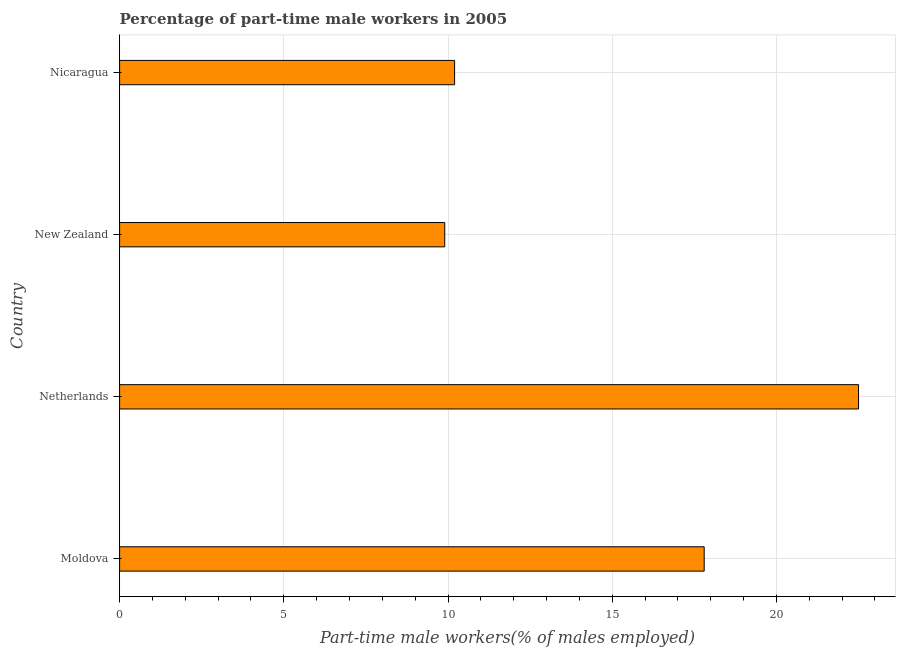Does the graph contain any zero values?
Make the answer very short. No. Does the graph contain grids?
Keep it short and to the point. Yes. What is the title of the graph?
Ensure brevity in your answer.  Percentage of part-time male workers in 2005. What is the label or title of the X-axis?
Your answer should be very brief. Part-time male workers(% of males employed). What is the percentage of part-time male workers in Nicaragua?
Your answer should be compact. 10.2. Across all countries, what is the minimum percentage of part-time male workers?
Provide a succinct answer. 9.9. In which country was the percentage of part-time male workers maximum?
Offer a terse response. Netherlands. In which country was the percentage of part-time male workers minimum?
Offer a very short reply. New Zealand. What is the sum of the percentage of part-time male workers?
Provide a short and direct response. 60.4. What is the difference between the percentage of part-time male workers in Netherlands and New Zealand?
Your response must be concise. 12.6. What is the average percentage of part-time male workers per country?
Your response must be concise. 15.1. What is the median percentage of part-time male workers?
Offer a very short reply. 14. In how many countries, is the percentage of part-time male workers greater than 19 %?
Provide a short and direct response. 1. What is the ratio of the percentage of part-time male workers in New Zealand to that in Nicaragua?
Your response must be concise. 0.97. Is the difference between the percentage of part-time male workers in New Zealand and Nicaragua greater than the difference between any two countries?
Ensure brevity in your answer.  No. Is the sum of the percentage of part-time male workers in Netherlands and New Zealand greater than the maximum percentage of part-time male workers across all countries?
Your answer should be compact. Yes. In how many countries, is the percentage of part-time male workers greater than the average percentage of part-time male workers taken over all countries?
Offer a very short reply. 2. What is the difference between two consecutive major ticks on the X-axis?
Make the answer very short. 5. Are the values on the major ticks of X-axis written in scientific E-notation?
Offer a terse response. No. What is the Part-time male workers(% of males employed) in Moldova?
Your response must be concise. 17.8. What is the Part-time male workers(% of males employed) in Netherlands?
Provide a short and direct response. 22.5. What is the Part-time male workers(% of males employed) of New Zealand?
Offer a terse response. 9.9. What is the Part-time male workers(% of males employed) of Nicaragua?
Your response must be concise. 10.2. What is the difference between the Part-time male workers(% of males employed) in Moldova and Nicaragua?
Make the answer very short. 7.6. What is the difference between the Part-time male workers(% of males employed) in Netherlands and New Zealand?
Your answer should be compact. 12.6. What is the difference between the Part-time male workers(% of males employed) in Netherlands and Nicaragua?
Keep it short and to the point. 12.3. What is the ratio of the Part-time male workers(% of males employed) in Moldova to that in Netherlands?
Offer a very short reply. 0.79. What is the ratio of the Part-time male workers(% of males employed) in Moldova to that in New Zealand?
Make the answer very short. 1.8. What is the ratio of the Part-time male workers(% of males employed) in Moldova to that in Nicaragua?
Your answer should be compact. 1.75. What is the ratio of the Part-time male workers(% of males employed) in Netherlands to that in New Zealand?
Offer a very short reply. 2.27. What is the ratio of the Part-time male workers(% of males employed) in Netherlands to that in Nicaragua?
Keep it short and to the point. 2.21. What is the ratio of the Part-time male workers(% of males employed) in New Zealand to that in Nicaragua?
Offer a very short reply. 0.97. 